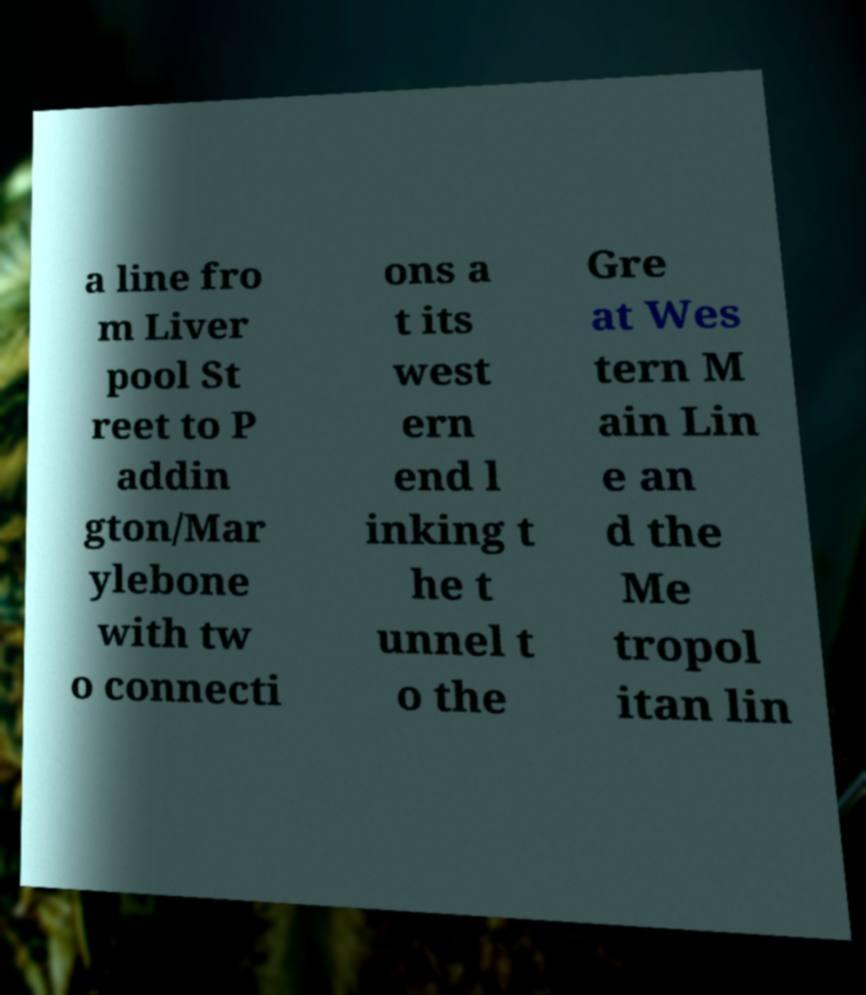For documentation purposes, I need the text within this image transcribed. Could you provide that? a line fro m Liver pool St reet to P addin gton/Mar ylebone with tw o connecti ons a t its west ern end l inking t he t unnel t o the Gre at Wes tern M ain Lin e an d the Me tropol itan lin 